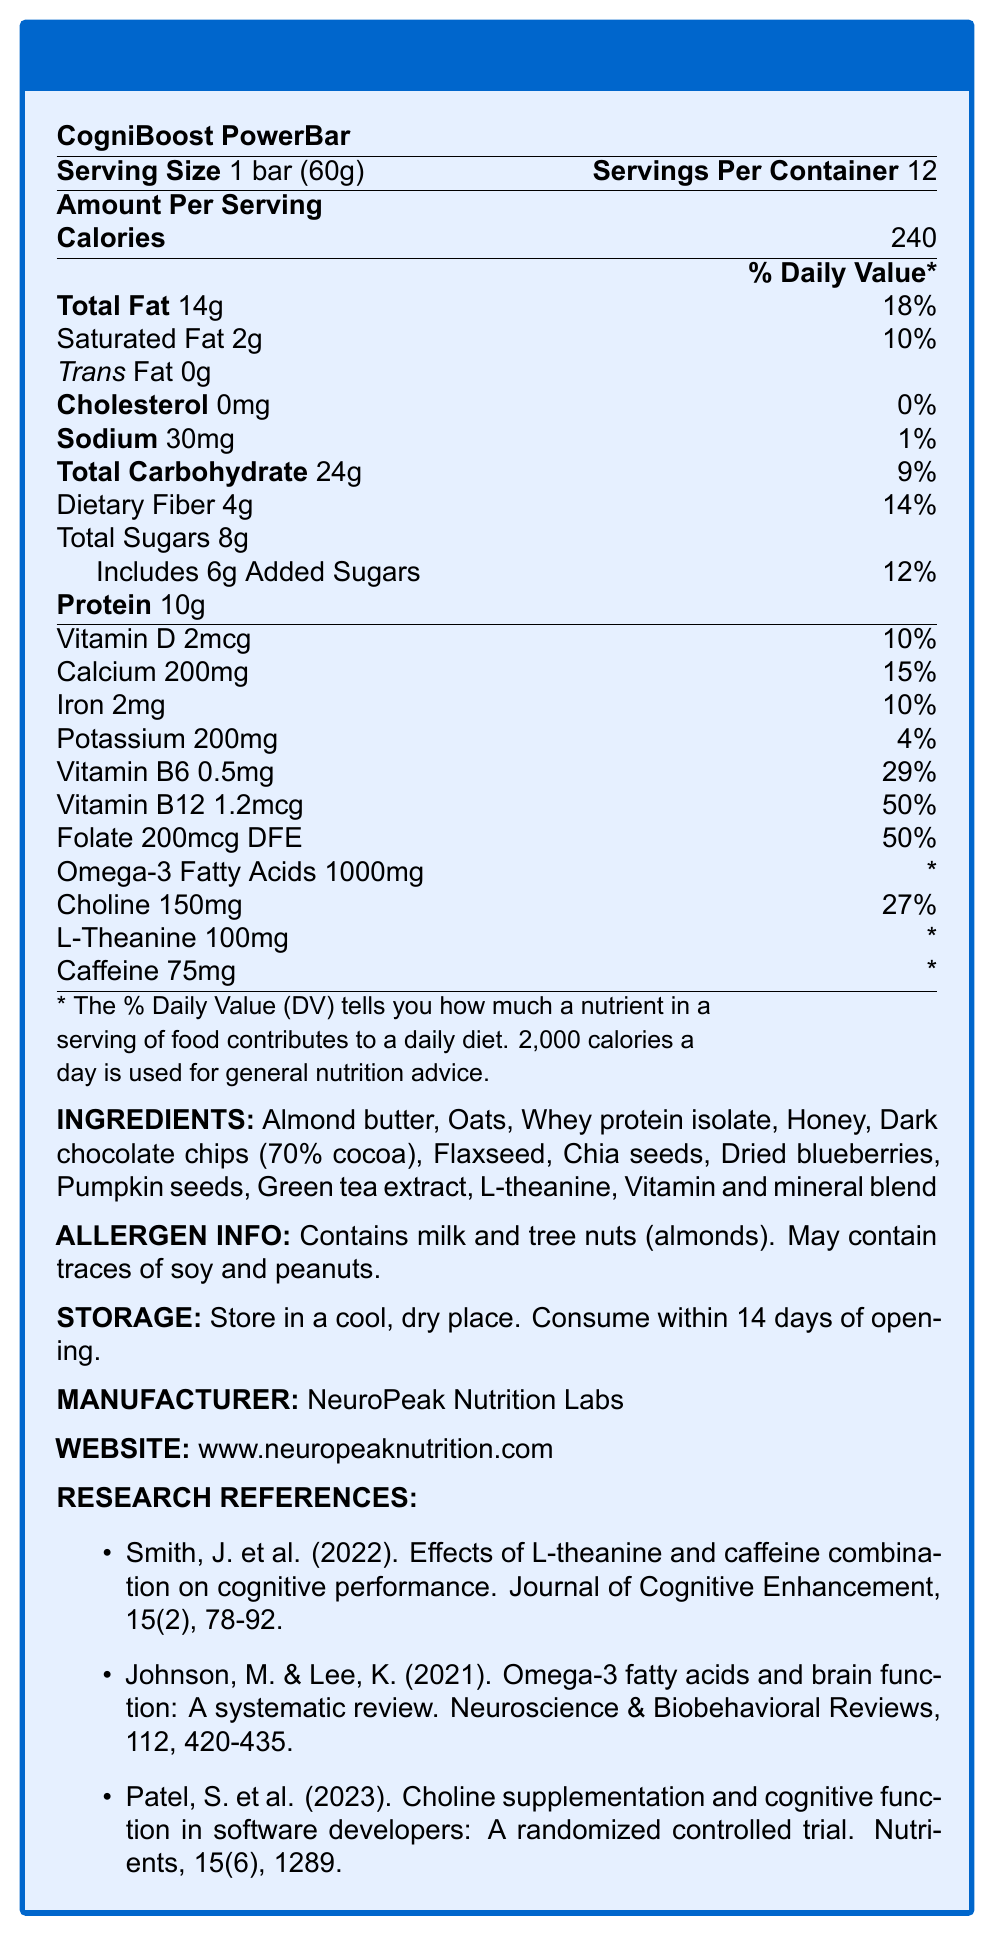what is the serving size for the CogniBoost PowerBar? The serving size is clearly mentioned next to the product name and under the "Serving Size" section.
Answer: 1 bar (60g) how many calories are in one serving of the CogniBoost PowerBar? The number of calories per serving is listed in the "Amount Per Serving" section under "Calories".
Answer: 240 how much protein is in one serving of the CogniBoost PowerBar? The amount of protein per serving is mentioned in the "Amount Per Serving" section under "Protein".
Answer: 10g how much vitamin B6 does one serving of the CogniBoost PowerBar provide? The amount of vitamin B6 is indicated in the nutritional details, listing it as 0.5mg.
Answer: 0.5mg what is the daily value percentage of vitamin B12 contained in one serving? The daily value percentage of vitamin B12 is provided in the "Amount Per Serving" section, indicated as 50%.
Answer: 50% Based on the information provided, which of the following ingredients are not included in the CogniBoost PowerBar? 
A. Almond butter
B. Coconut oil
C. Whey protein isolate
D. Dried blueberries The ingredient list includes almond butter, whey protein isolate, and dried blueberries, while coconut oil is not mentioned.
Answer: B What is the daily value percentage of dietary fiber in one serving of the CogniBoost PowerBar? A. 9% B. 14% C. 18% D. 27% The daily value percentage of dietary fiber per serving is indicated as 14%.
Answer: B Does the CogniBoost PowerBar contain any trans fat? The "Amount Per Serving" section clearly shows that the amount of trans fat is 0g.
Answer: No What are the storage instructions for the CogniBoost PowerBar? The storage instructions are provided in the final section of the document.
Answer: Store in a cool, dry place. Consume within 14 days of opening. How many servings are there per container of the CogniBoost PowerBar? The number of servings per container is listed next to the serving size at the top.
Answer: 12 Summarize the content of the document. The document comprises various sections that break down the nutritional content of the PowerBar, along with additional product and research information for full transparency.
Answer: The document provides a nutrition facts label for the CogniBoost PowerBar, detailing serving size, servings per container, calories, macronutrient and micronutrient amounts, daily values, ingredient list, allergen information, storage instructions, manufacturer details, and research references. How much choline is present in one serving, and what is its daily value percentage? Choline content per serving is listed as 150mg with a daily value percentage of 27% under the micronutrient information.
Answer: 150mg, 27% What is the main function of the vitamin and mineral blend in the CogniBoost PowerBar? The document lists the presence of a vitamin and mineral blend but does not provide specific details about its function.
Answer: Not enough information How much added sugars are in one serving? The amount of added sugars is explicitly mentioned under the 'Total Sugars' section, listing 6g of added sugars per serving.
Answer: 6g What is the name of the manufacturer of the CogniBoost PowerBar? The manufacturer's name is provided in the "Manufacturer" section near the end of the document.
Answer: NeuroPeak Nutrition Labs What amount of omega-3 fatty acids does one serving of the CogniBoost PowerBar contain? The amount of omega-3 fatty acids per serving is mentioned in the nutritional details, listing it as 1000mg.
Answer: 1000mg 